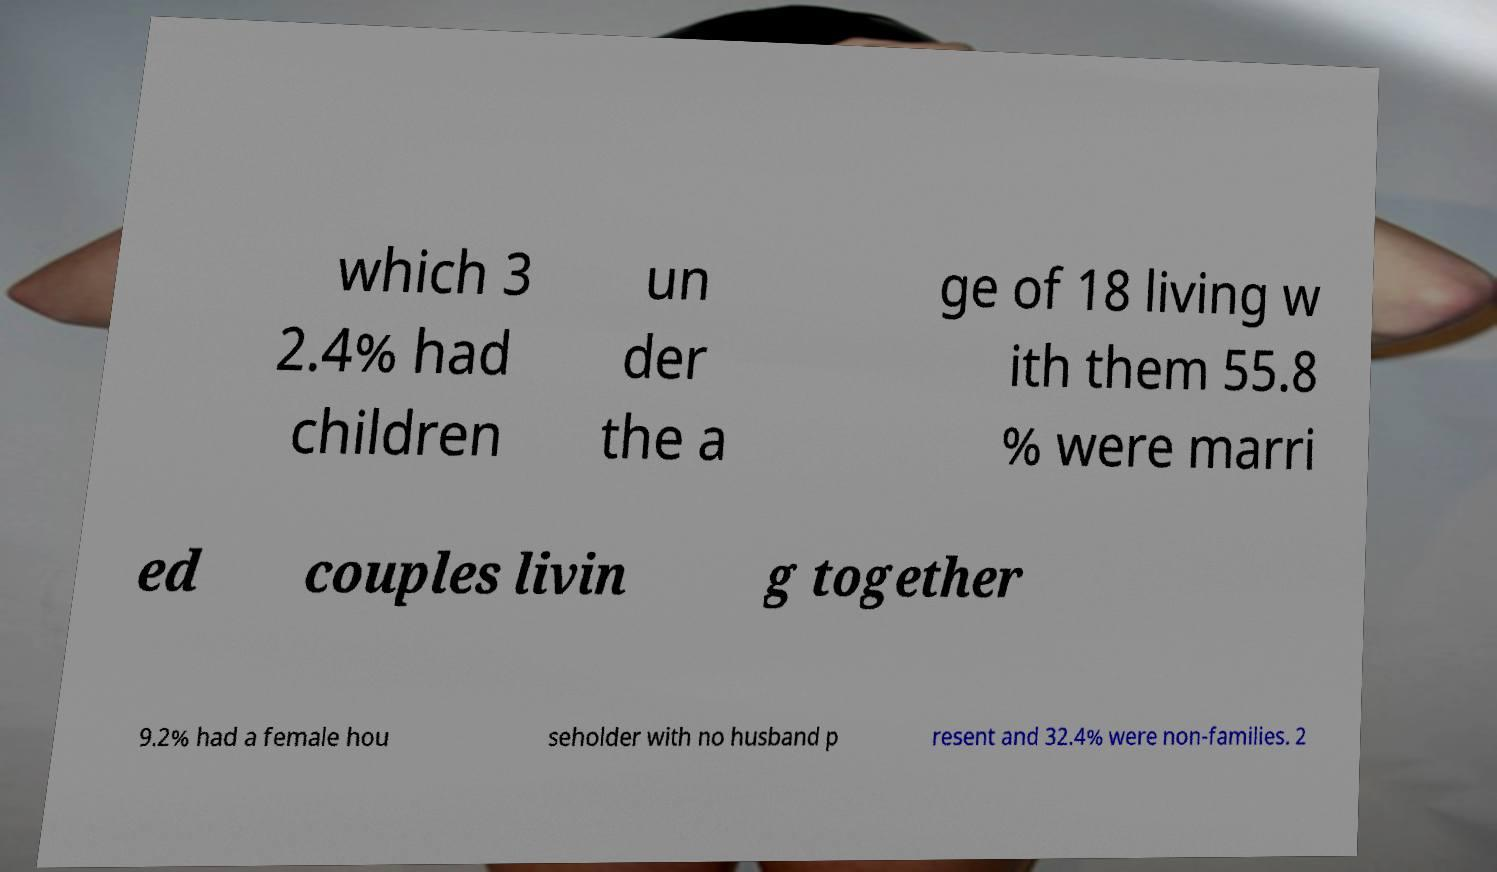Please identify and transcribe the text found in this image. which 3 2.4% had children un der the a ge of 18 living w ith them 55.8 % were marri ed couples livin g together 9.2% had a female hou seholder with no husband p resent and 32.4% were non-families. 2 